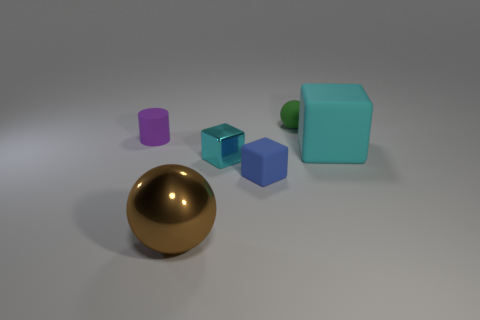Do the brown object and the blue object have the same material?
Provide a succinct answer. No. How many things are either tiny gray metallic cubes or cyan blocks?
Make the answer very short. 2. How many other things are the same size as the brown ball?
Offer a terse response. 1. Is the color of the rubber cylinder the same as the big thing on the right side of the large brown sphere?
Make the answer very short. No. How many balls are small purple rubber things or blue things?
Make the answer very short. 0. Is there any other thing of the same color as the big metal sphere?
Ensure brevity in your answer.  No. What is the cyan thing on the right side of the object that is behind the purple matte cylinder made of?
Keep it short and to the point. Rubber. Do the brown thing and the large object that is on the right side of the large metallic ball have the same material?
Provide a succinct answer. No. How many things are small matte objects in front of the cyan matte thing or large purple matte spheres?
Offer a terse response. 1. Are there any large matte objects of the same color as the large metallic sphere?
Offer a very short reply. No. 